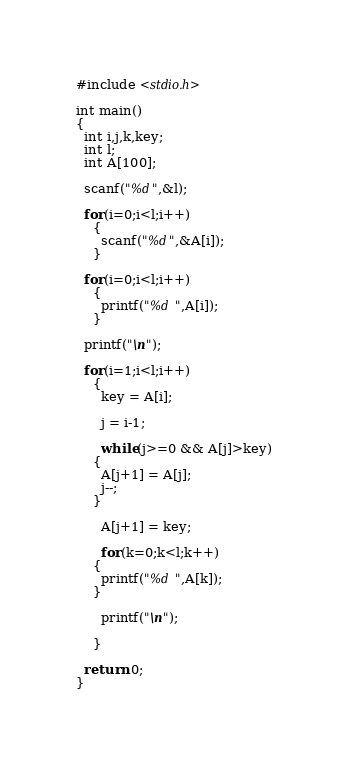Convert code to text. <code><loc_0><loc_0><loc_500><loc_500><_C_>#include <stdio.h>

int main()
{
  int i,j,k,key;
  int l;
  int A[100];
  
  scanf("%d",&l);
  
  for(i=0;i<l;i++)
    {
      scanf("%d",&A[i]);
    }
  
  for(i=0;i<l;i++)
    {
      printf("%d ",A[i]);
    }
  
  printf("\n");
  
  for(i=1;i<l;i++)
    {
      key = A[i];

      j = i-1;
      
      while(j>=0 && A[j]>key)
	{
	  A[j+1] = A[j];
	  j--;
	}
  
      A[j+1] = key;
      
      for(k=0;k<l;k++)
	{
	  printf("%d ",A[k]);
	}
      
      printf("\n");
     
    }

  return 0;
}</code> 